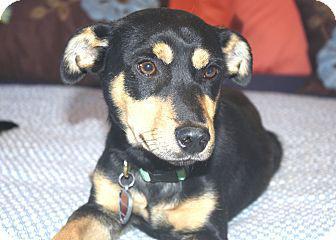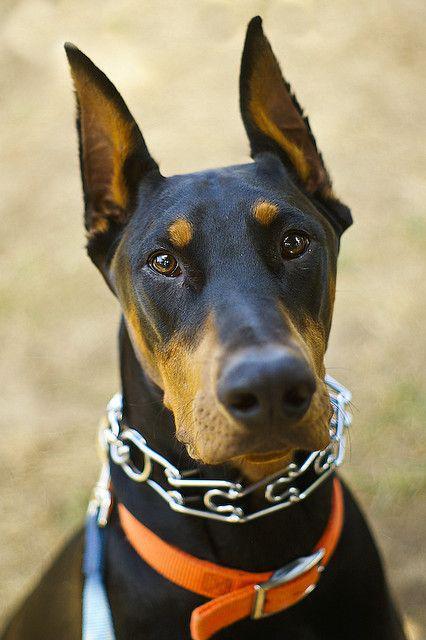The first image is the image on the left, the second image is the image on the right. Assess this claim about the two images: "The ears of two dobermans are sticking straight up.". Correct or not? Answer yes or no. No. The first image is the image on the left, the second image is the image on the right. Examine the images to the left and right. Is the description "Each image shows one forward-facing adult doberman with pointy erect ears." accurate? Answer yes or no. No. 